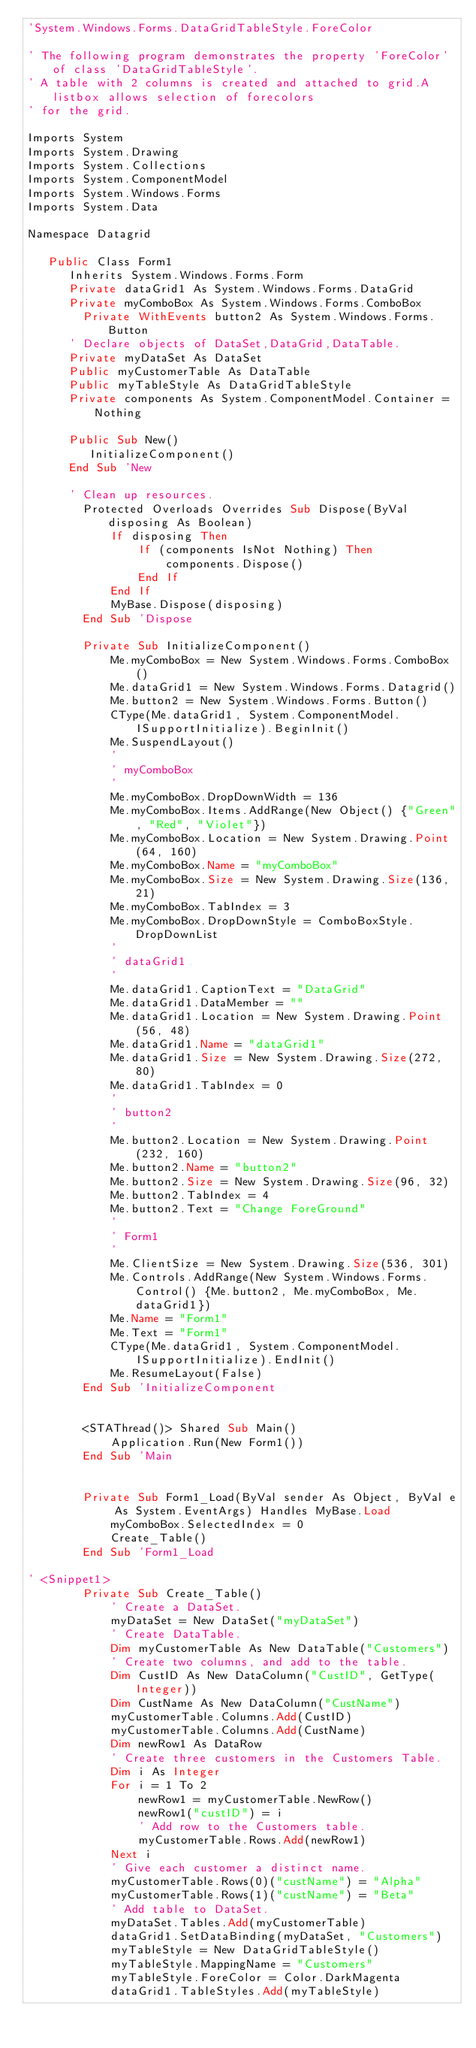<code> <loc_0><loc_0><loc_500><loc_500><_VisualBasic_>'System.Windows.Forms.DataGridTableStyle.ForeColor

' The following program demonstrates the property 'ForeColor' of class 'DataGridTableStyle'.
' A table with 2 columns is created and attached to grid.A listbox allows selection of forecolors
' for the grid.

Imports System
Imports System.Drawing
Imports System.Collections
Imports System.ComponentModel
Imports System.Windows.Forms
Imports System.Data

Namespace Datagrid

   Public Class Form1
      Inherits System.Windows.Forms.Form
      Private dataGrid1 As System.Windows.Forms.DataGrid
      Private myComboBox As System.Windows.Forms.ComboBox
        Private WithEvents button2 As System.Windows.Forms.Button
      ' Declare objects of DataSet,DataGrid,DataTable.
      Private myDataSet As DataSet
      Public myCustomerTable As DataTable
      Public myTableStyle As DataGridTableStyle
      Private components As System.ComponentModel.Container = Nothing
      
      Public Sub New()
         InitializeComponent()
      End Sub 'New
      
      ' Clean up resources.
        Protected Overloads Overrides Sub Dispose(ByVal disposing As Boolean)
            If disposing Then
                If (components IsNot Nothing) Then
                    components.Dispose()
                End If
            End If
            MyBase.Dispose(disposing)
        End Sub 'Dispose

        Private Sub InitializeComponent()
            Me.myComboBox = New System.Windows.Forms.ComboBox()
            Me.dataGrid1 = New System.Windows.Forms.Datagrid()
            Me.button2 = New System.Windows.Forms.Button()
            CType(Me.dataGrid1, System.ComponentModel.ISupportInitialize).BeginInit()
            Me.SuspendLayout()
            ' 
            ' myComboBox
            ' 
            Me.myComboBox.DropDownWidth = 136
            Me.myComboBox.Items.AddRange(New Object() {"Green", "Red", "Violet"})
            Me.myComboBox.Location = New System.Drawing.Point(64, 160)
            Me.myComboBox.Name = "myComboBox"
            Me.myComboBox.Size = New System.Drawing.Size(136, 21)
            Me.myComboBox.TabIndex = 3
            Me.myComboBox.DropDownStyle = ComboBoxStyle.DropDownList
            ' 
            ' dataGrid1
            ' 
            Me.dataGrid1.CaptionText = "DataGrid"
            Me.dataGrid1.DataMember = ""
            Me.dataGrid1.Location = New System.Drawing.Point(56, 48)
            Me.dataGrid1.Name = "dataGrid1"
            Me.dataGrid1.Size = New System.Drawing.Size(272, 80)
            Me.dataGrid1.TabIndex = 0
            ' 
            ' button2
            ' 
            Me.button2.Location = New System.Drawing.Point(232, 160)
            Me.button2.Name = "button2"
            Me.button2.Size = New System.Drawing.Size(96, 32)
            Me.button2.TabIndex = 4
            Me.button2.Text = "Change ForeGround"
            ' 
            ' Form1
            ' 
            Me.ClientSize = New System.Drawing.Size(536, 301)
            Me.Controls.AddRange(New System.Windows.Forms.Control() {Me.button2, Me.myComboBox, Me.dataGrid1})
            Me.Name = "Form1"
            Me.Text = "Form1"
            CType(Me.dataGrid1, System.ComponentModel.ISupportInitialize).EndInit()
            Me.ResumeLayout(False)
        End Sub 'InitializeComponent


        <STAThread()> Shared Sub Main()
            Application.Run(New Form1())
        End Sub 'Main


        Private Sub Form1_Load(ByVal sender As Object, ByVal e As System.EventArgs) Handles MyBase.Load
            myComboBox.SelectedIndex = 0
            Create_Table()
        End Sub 'Form1_Load

' <Snippet1>
        Private Sub Create_Table()
            ' Create a DataSet.
            myDataSet = New DataSet("myDataSet")
            ' Create DataTable.
            Dim myCustomerTable As New DataTable("Customers")
            ' Create two columns, and add to the table.
            Dim CustID As New DataColumn("CustID", GetType(Integer))
            Dim CustName As New DataColumn("CustName")
            myCustomerTable.Columns.Add(CustID)
            myCustomerTable.Columns.Add(CustName)
            Dim newRow1 As DataRow
            ' Create three customers in the Customers Table.
            Dim i As Integer
            For i = 1 To 2
                newRow1 = myCustomerTable.NewRow()
                newRow1("custID") = i
                ' Add row to the Customers table.
                myCustomerTable.Rows.Add(newRow1)
            Next i
            ' Give each customer a distinct name.
            myCustomerTable.Rows(0)("custName") = "Alpha"
            myCustomerTable.Rows(1)("custName") = "Beta"
            ' Add table to DataSet.
            myDataSet.Tables.Add(myCustomerTable)
            dataGrid1.SetDataBinding(myDataSet, "Customers")
            myTableStyle = New DataGridTableStyle()
            myTableStyle.MappingName = "Customers"
            myTableStyle.ForeColor = Color.DarkMagenta
            dataGrid1.TableStyles.Add(myTableStyle)</code> 